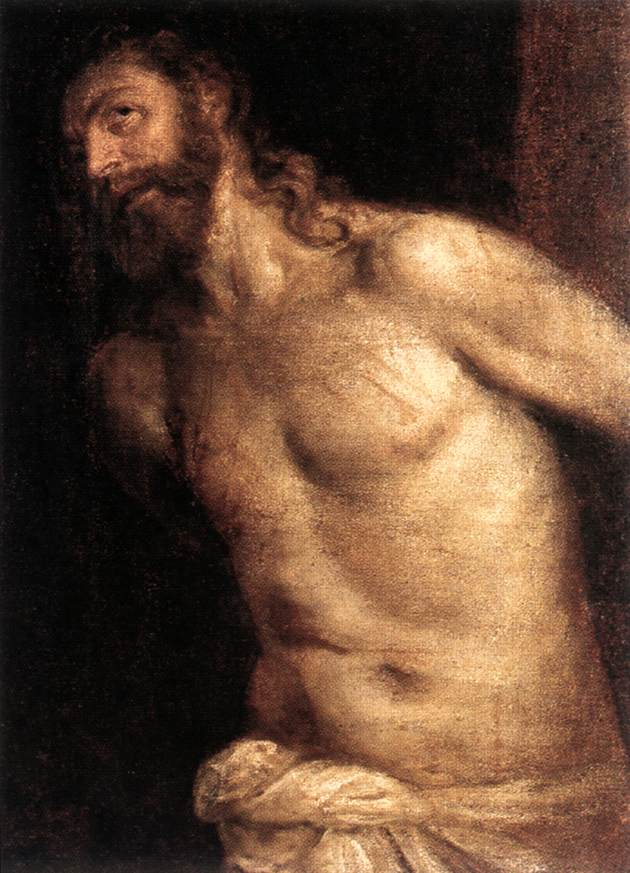How does the use of light contribute to the overall mood and thematic elements of the painting? The use of chiaroscuro—a technique where light sharply contrasts with shadow—is instrumental in creating a dramatic, almost theatrical effect. This not only focuses the viewer’s attention on the figure, particularly his face and upper body, but also adds a layer of depth to the emotional and spiritual turmoil possibly experienced by the figure. The dimly lit surroundings help isolate the subject, making his illuminated form a symbol of divine intervention or inner enlightenment, enhancing the painting’s emotional impact. 